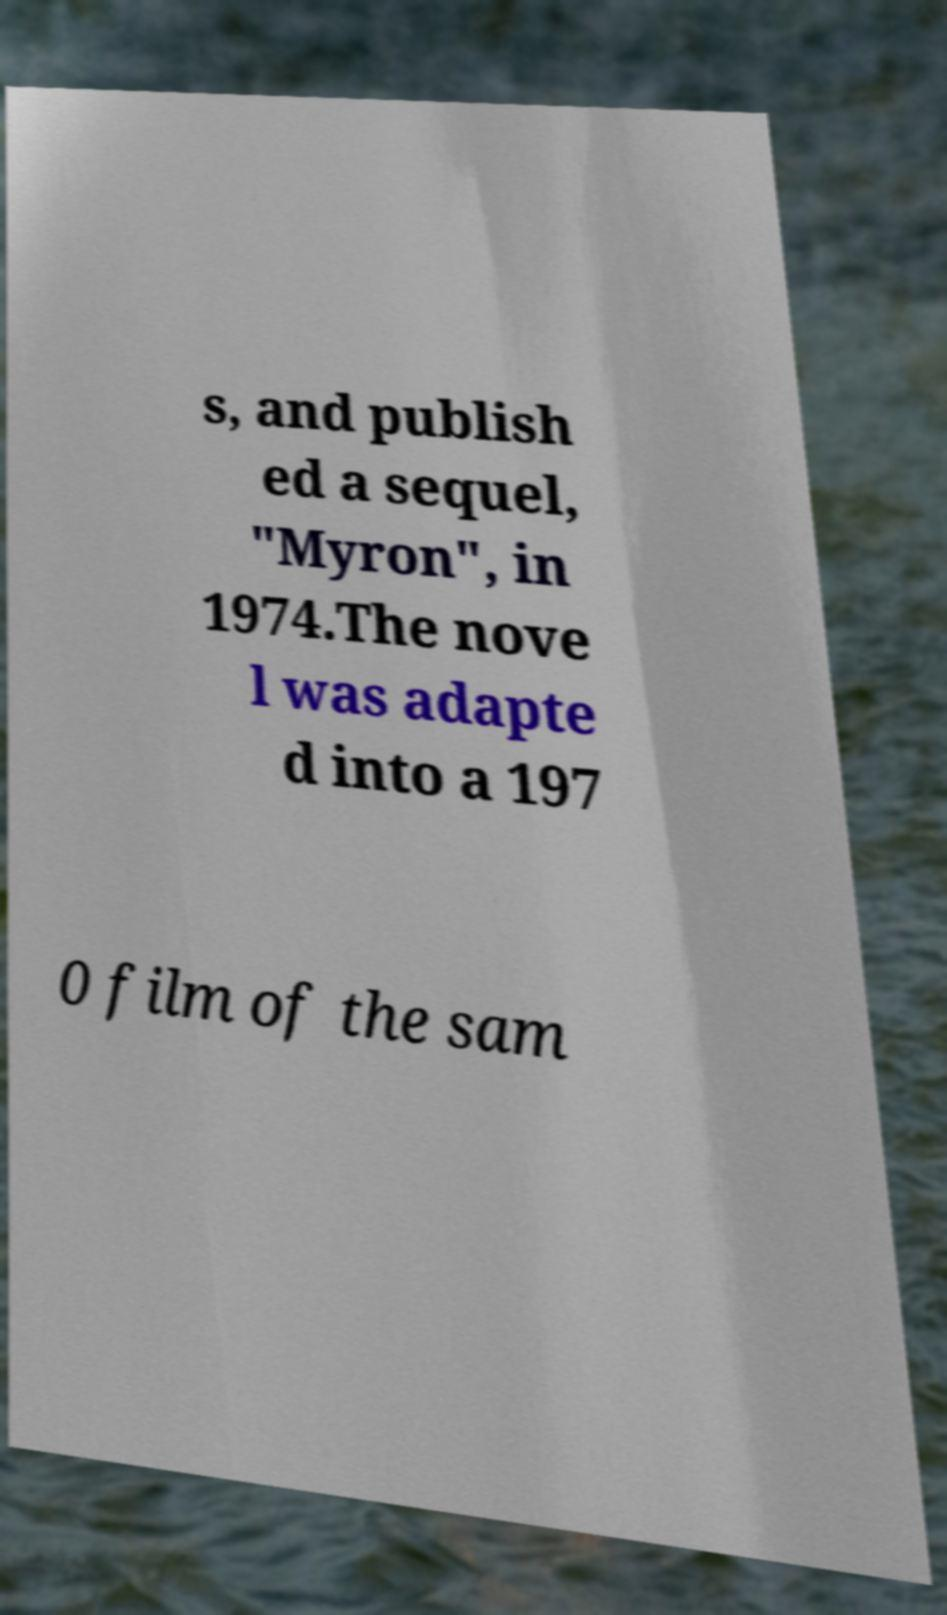There's text embedded in this image that I need extracted. Can you transcribe it verbatim? s, and publish ed a sequel, "Myron", in 1974.The nove l was adapte d into a 197 0 film of the sam 